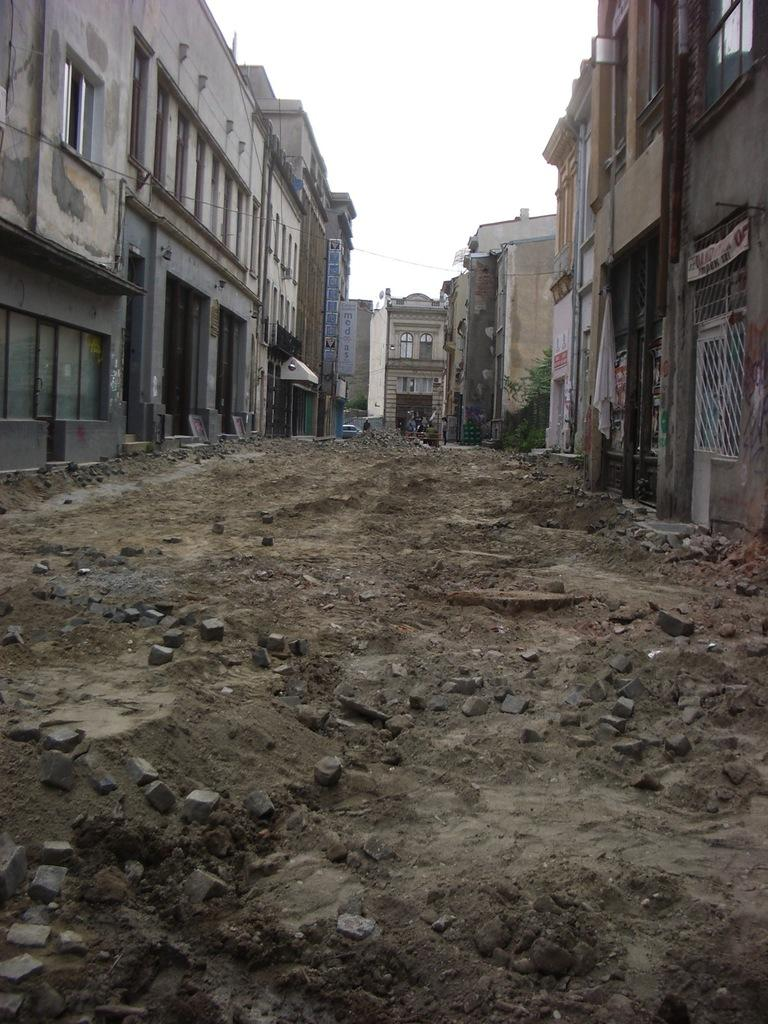What can be seen on the path in the image? There are stones on the path in the image. What is located on the left side of the path? There are buildings on the left side of the path in the image. What is located on the right side of the path? There are buildings on the right side of the path in the image. What are the boards used for in the image? The boards are used to separate the path from the buildings on the left and right side of the path. What is visible behind the buildings in the image? The sky is visible behind the buildings in the image. What type of leather is used to make the brake on the back of the building in the image? There is no leather or brake present in the image; it features a path with stones and buildings on both sides. 